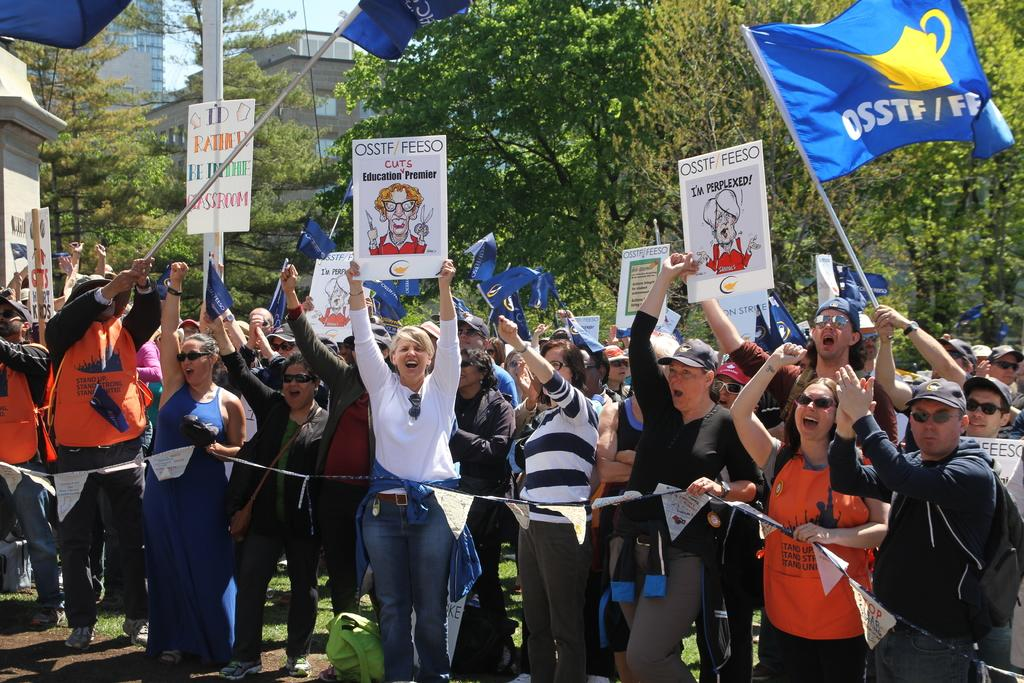What are the people in the image doing? The people in the image are standing on the ground. What are some of the people holding in the image? Some of the people are holding placards and flags. What can be seen in the background of the image? There are trees, buildings, and the sky visible in the background of the image. What type of pen is being used to write on the plot in the image? There is no pen or plot present in the image; it features people standing with placards and flags. 